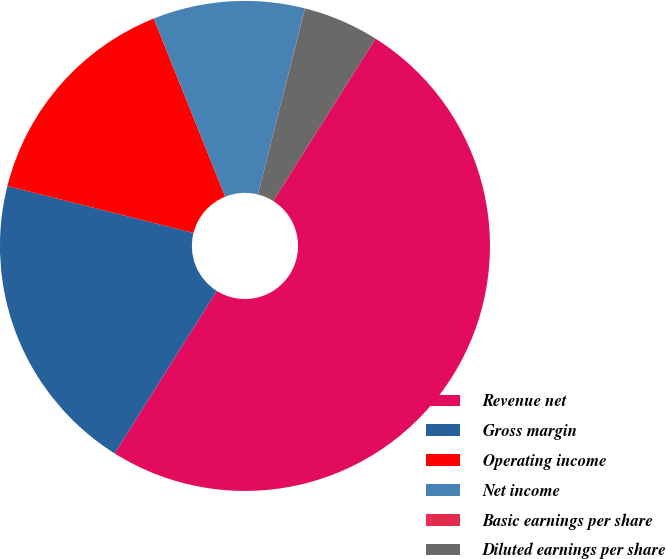Convert chart. <chart><loc_0><loc_0><loc_500><loc_500><pie_chart><fcel>Revenue net<fcel>Gross margin<fcel>Operating income<fcel>Net income<fcel>Basic earnings per share<fcel>Diluted earnings per share<nl><fcel>49.99%<fcel>20.0%<fcel>15.0%<fcel>10.0%<fcel>0.01%<fcel>5.0%<nl></chart> 